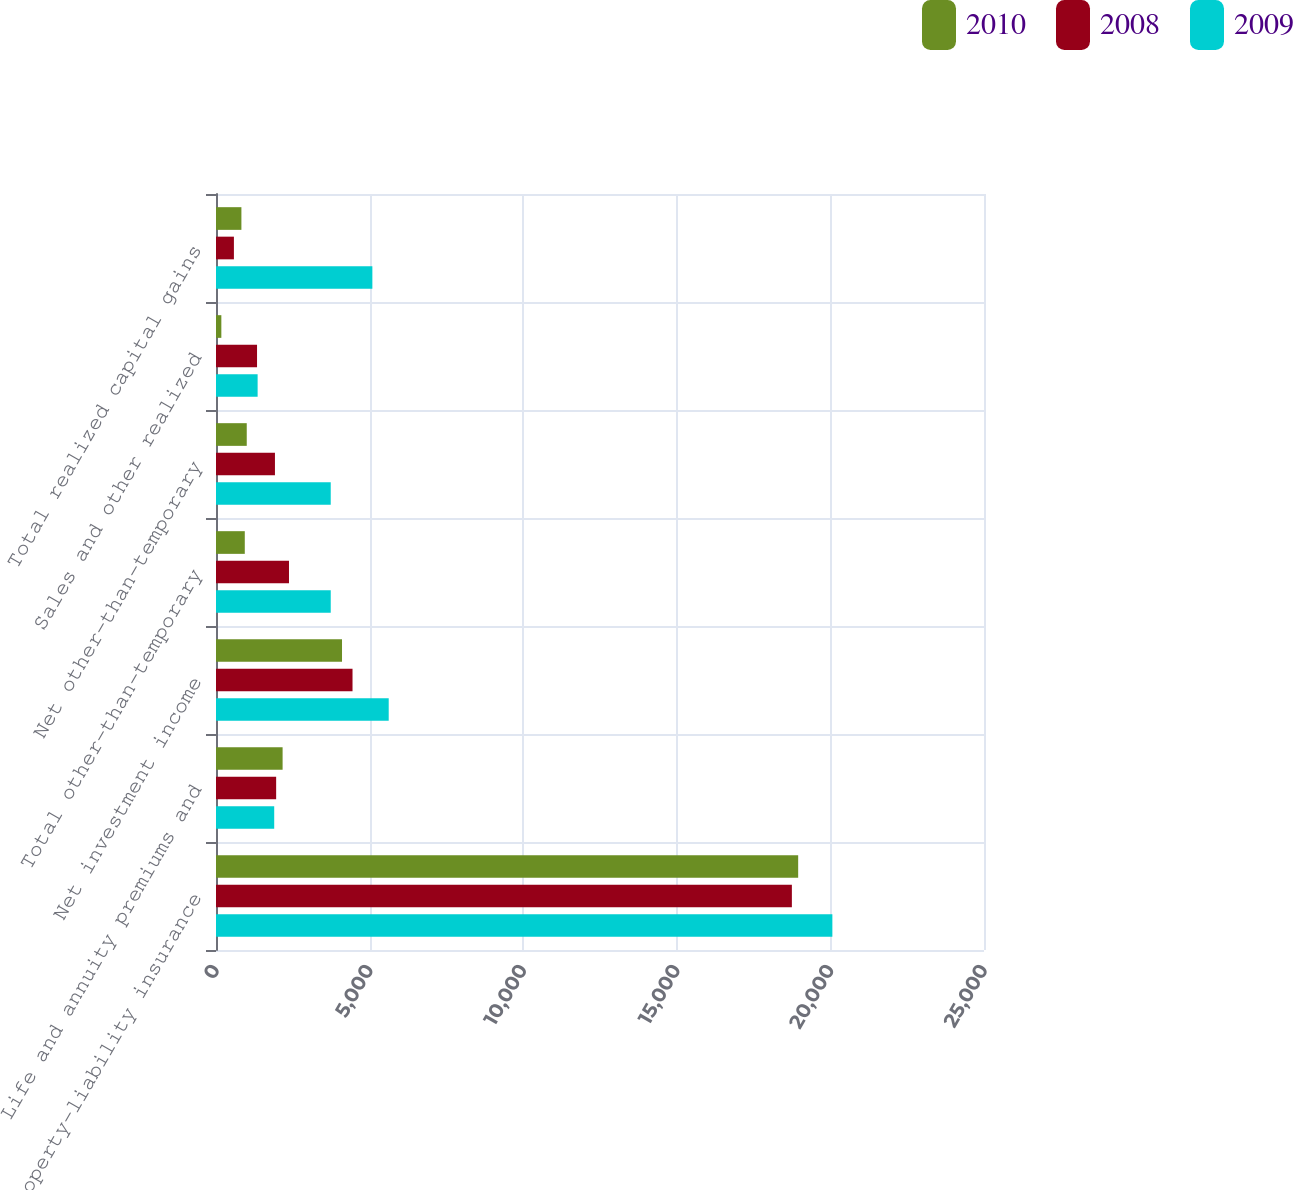<chart> <loc_0><loc_0><loc_500><loc_500><stacked_bar_chart><ecel><fcel>Property-liability insurance<fcel>Life and annuity premiums and<fcel>Net investment income<fcel>Total other-than-temporary<fcel>Net other-than-temporary<fcel>Sales and other realized<fcel>Total realized capital gains<nl><fcel>2010<fcel>18951<fcel>2168<fcel>4102<fcel>937<fcel>1001<fcel>174<fcel>827<nl><fcel>2008<fcel>18746<fcel>1958<fcel>4444<fcel>2376<fcel>1919<fcel>1336<fcel>583<nl><fcel>2009<fcel>20064<fcel>1895<fcel>5622<fcel>3735<fcel>3735<fcel>1355<fcel>5090<nl></chart> 